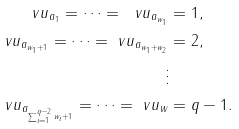<formula> <loc_0><loc_0><loc_500><loc_500>\ v u _ { a _ { 1 } } = \cdots = \ v u _ { a _ { w _ { 1 } } } & = 1 , \\ \ v u _ { a _ { w _ { 1 } + 1 } } = \cdots = \ v u _ { a _ { w _ { 1 } + w _ { 2 } } } & = 2 , \\ \vdots \\ \ v u _ { a _ { \sum _ { i = 1 } ^ { q - 2 } w _ { i } + 1 } } = \cdots = \ v u _ { w } & = q - 1 .</formula> 